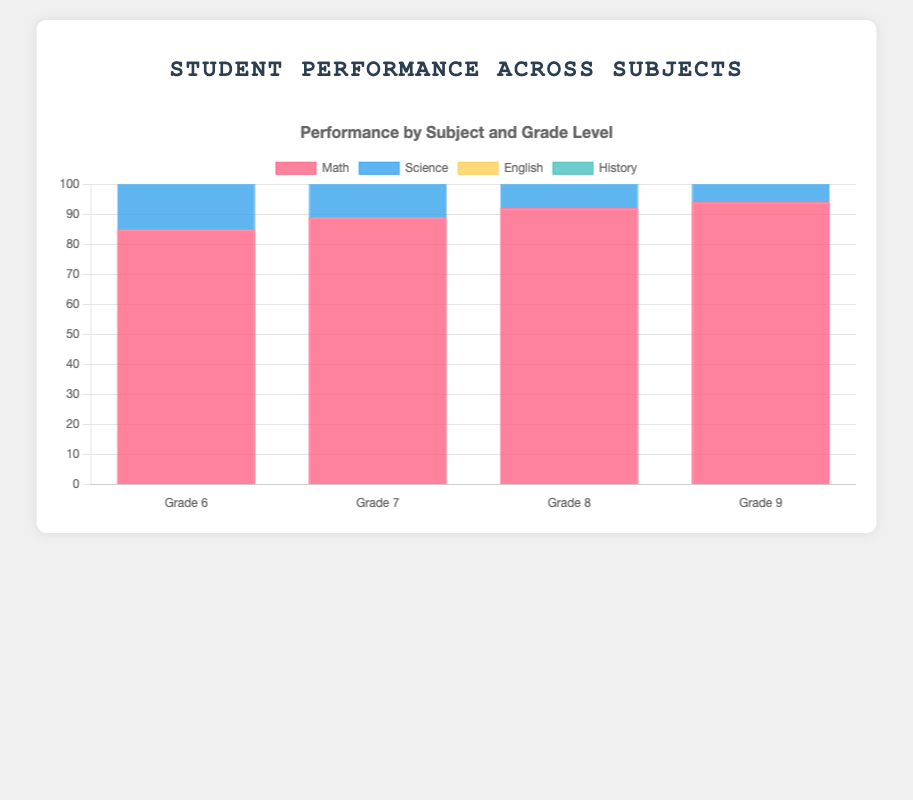What is the average performance in Science across all grades? To get the average performance in Science, sum the Science scores from each grade and divide by the number of grades. The scores are 78, 81, 85, and 88. The sum is 78 + 81 + 85 + 88 = 332. There are 4 grades, so the average is 332/4 = 83.
Answer: 83 Which grade level scored the highest in Math? To find the highest score in Math, compare the Math scores for all grade levels. The Math scores are 85 (Grade 6), 89 (Grade 7), 92 (Grade 8), and 94 (Grade 9). The highest score is 94 in Grade 9.
Answer: Grade 9 Is the performance in English higher in Grade 7 or Grade 8? Compare the English scores for Grade 7 and Grade 8. Grade 7 has a score of 86, and Grade 8 has a score of 90. Since 90 is greater than 86, the performance in English is higher in Grade 8.
Answer: Grade 8 What is the total score for Grade 6 across all subjects? Sum the scores for all subjects in Grade 6. The scores are 85 (Math), 78 (Science), 88 (English), and 74 (History). The total is 85 + 78 + 88 + 74 = 325.
Answer: 325 Which subject shows the greatest improvement from Grade 6 to Grade 9? Calculate the difference between Grade 9 and Grade 6 scores for each subject. Math: 94 - 85 = 9; Science: 88 - 78 = 10; English: 91 - 88 = 3; History: 83 - 74 = 9. The greatest improvement is in Science, with a 10-point increase.
Answer: Science In which grade is the performance in History the lowest? Compare the History scores for all grade levels. Grade 6 has a score of 74, Grade 7 has 76, Grade 8 has 80, and Grade 9 has 83. The lowest score is 74 in Grade 6.
Answer: Grade 6 What is the combined average performance in Math and Science for Grade 8? First, sum the Math and Science scores for Grade 8. Math: 92, Science: 85. The total is 92 + 85 = 177. Then, divide by the number of subjects, which is 2. So, 177/2 = 88.5.
Answer: 88.5 How does the performance in History change from Grade 7 to Grade 8? Subtract the Grade 7 History score from the Grade 8 History score to find the difference. Grade 7 has a score of 76, and Grade 8 has a score of 80. The change is 80 - 76 = 4.
Answer: Increased by 4 Which subject has the least variation in scores across all grades? Calculate the range (difference between the highest and lowest scores) for each subject. Math: 94 - 85 = 9, Science: 88 - 78 = 10, English: 91 - 86 = 5, History: 83 - 74 = 9. The subject with the least variation is English, with a 5-point range.
Answer: English 